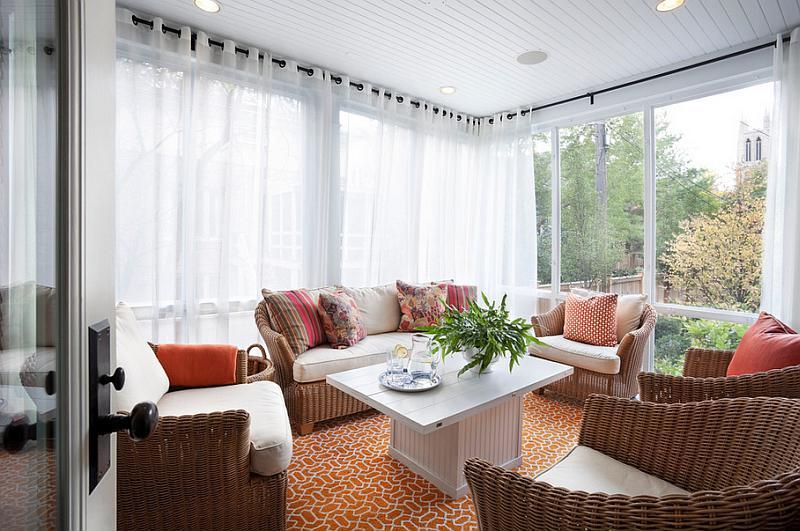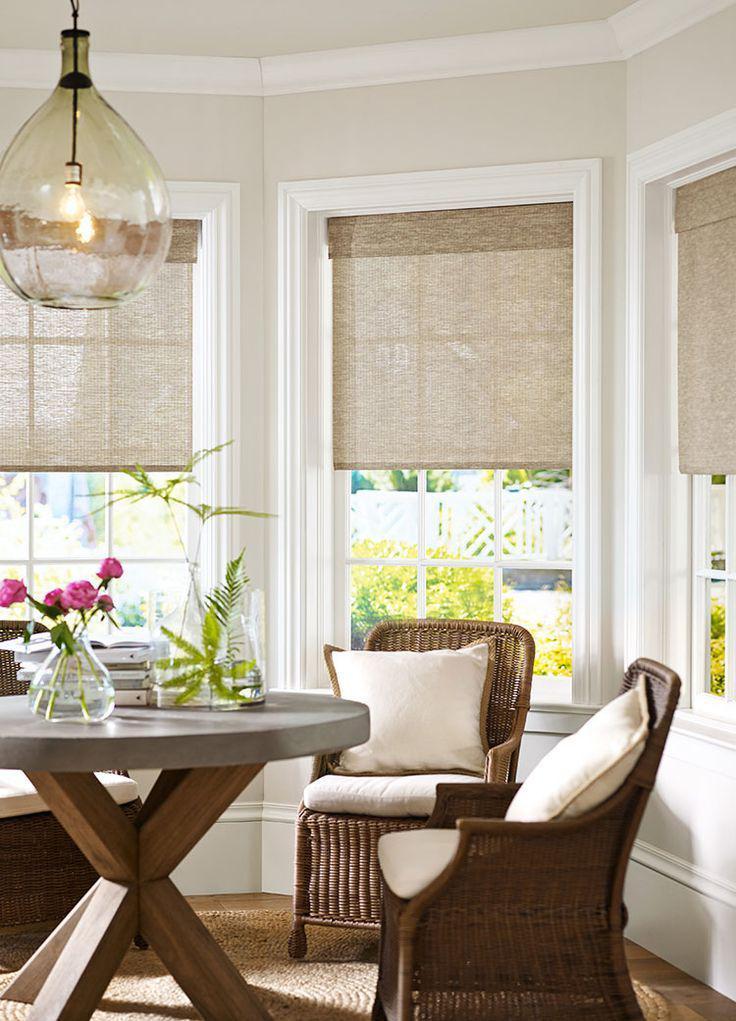The first image is the image on the left, the second image is the image on the right. For the images shown, is this caption "One set of curtains is closed." true? Answer yes or no. Yes. The first image is the image on the left, the second image is the image on the right. Analyze the images presented: Is the assertion "Sheer white drapes hang from a black horizontal bar in a white room with seating furniture, in one image." valid? Answer yes or no. Yes. 